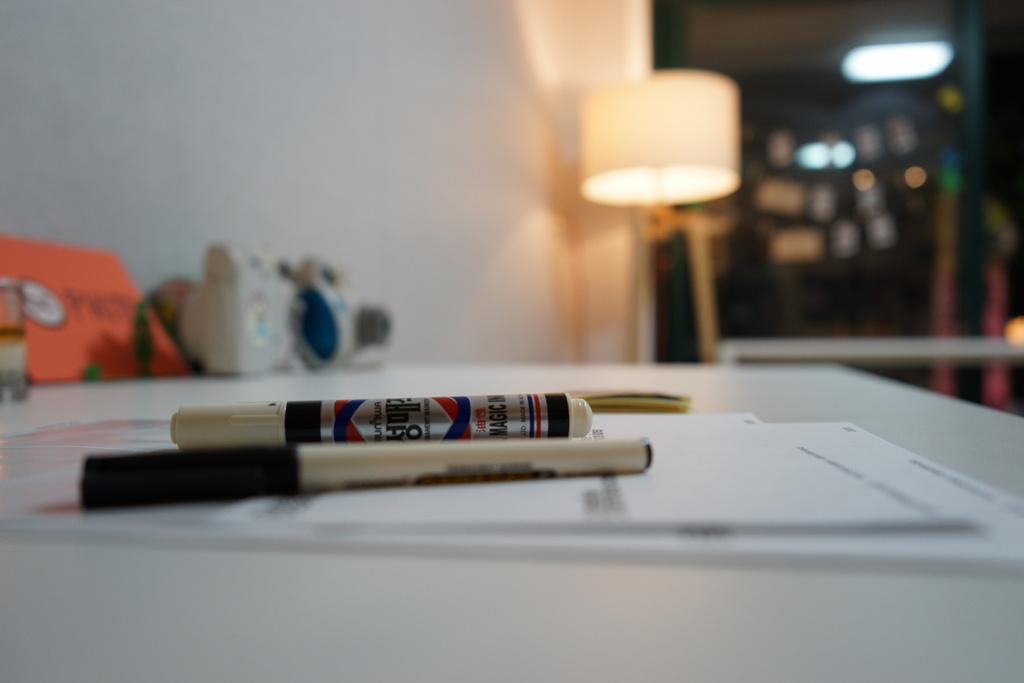What type of furniture is present in the image? There is a table in the image. What items can be seen on the table? The table has markers, papers, and books on it. Where is the lamp located in the image? The lamp is beside a wall in the image. What type of wall is present in the image? There is a glass wall in the image. What type of shop can be seen through the glass wall in the image? There is no shop visible through the glass wall in the image; it is a glass wall without any visible shops. What type of shade is provided by the lamp in the image? The lamp in the image does not provide any shade, as it is not mentioned to have any shading features. 